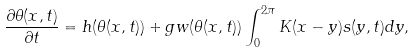Convert formula to latex. <formula><loc_0><loc_0><loc_500><loc_500>\frac { \partial \theta ( x , t ) } { \partial t } = h ( \theta ( x , t ) ) + g w ( \theta ( x , t ) ) \int _ { 0 } ^ { 2 \pi } { K ( x - y ) s ( y , t ) d y } ,</formula> 